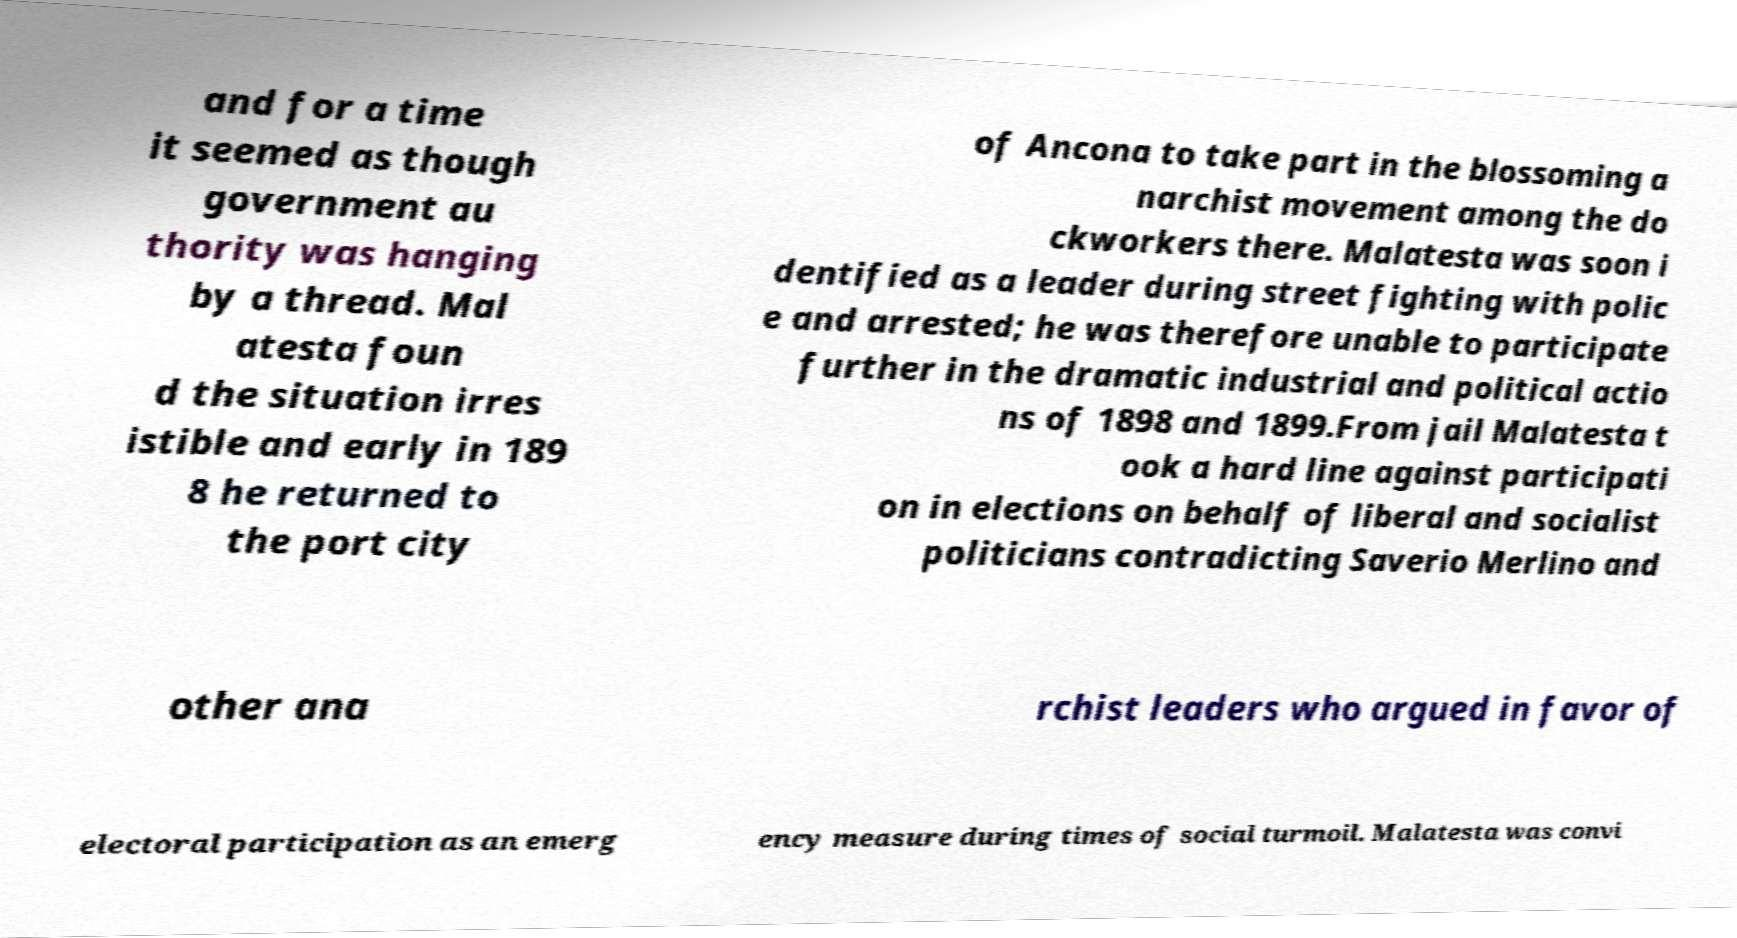For documentation purposes, I need the text within this image transcribed. Could you provide that? and for a time it seemed as though government au thority was hanging by a thread. Mal atesta foun d the situation irres istible and early in 189 8 he returned to the port city of Ancona to take part in the blossoming a narchist movement among the do ckworkers there. Malatesta was soon i dentified as a leader during street fighting with polic e and arrested; he was therefore unable to participate further in the dramatic industrial and political actio ns of 1898 and 1899.From jail Malatesta t ook a hard line against participati on in elections on behalf of liberal and socialist politicians contradicting Saverio Merlino and other ana rchist leaders who argued in favor of electoral participation as an emerg ency measure during times of social turmoil. Malatesta was convi 